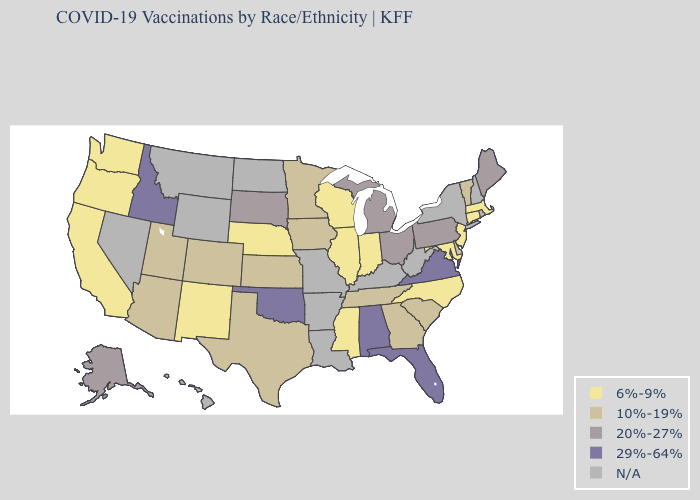What is the lowest value in the West?
Keep it brief. 6%-9%. What is the value of Oregon?
Write a very short answer. 6%-9%. Does the first symbol in the legend represent the smallest category?
Concise answer only. Yes. Which states hav the highest value in the MidWest?
Answer briefly. Michigan, Ohio, South Dakota. Which states have the highest value in the USA?
Quick response, please. Alabama, Florida, Idaho, Oklahoma, Virginia. Among the states that border Wyoming , which have the lowest value?
Answer briefly. Nebraska. What is the value of California?
Concise answer only. 6%-9%. Which states have the lowest value in the South?
Give a very brief answer. Maryland, Mississippi, North Carolina. Name the states that have a value in the range 6%-9%?
Quick response, please. California, Connecticut, Illinois, Indiana, Maryland, Massachusetts, Mississippi, Nebraska, New Jersey, New Mexico, North Carolina, Oregon, Washington, Wisconsin. Does Idaho have the lowest value in the USA?
Answer briefly. No. Which states have the lowest value in the South?
Quick response, please. Maryland, Mississippi, North Carolina. Does Illinois have the highest value in the MidWest?
Short answer required. No. Among the states that border Oklahoma , which have the lowest value?
Be succinct. New Mexico. 